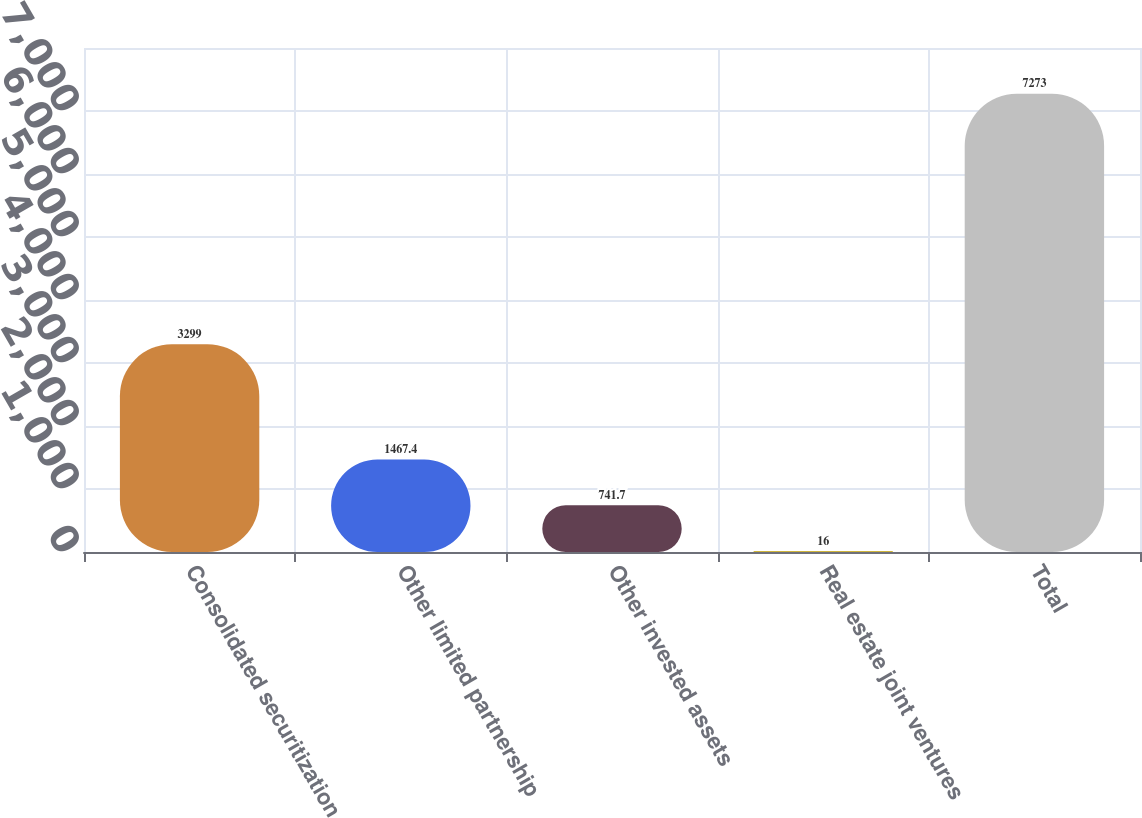Convert chart. <chart><loc_0><loc_0><loc_500><loc_500><bar_chart><fcel>Consolidated securitization<fcel>Other limited partnership<fcel>Other invested assets<fcel>Real estate joint ventures<fcel>Total<nl><fcel>3299<fcel>1467.4<fcel>741.7<fcel>16<fcel>7273<nl></chart> 